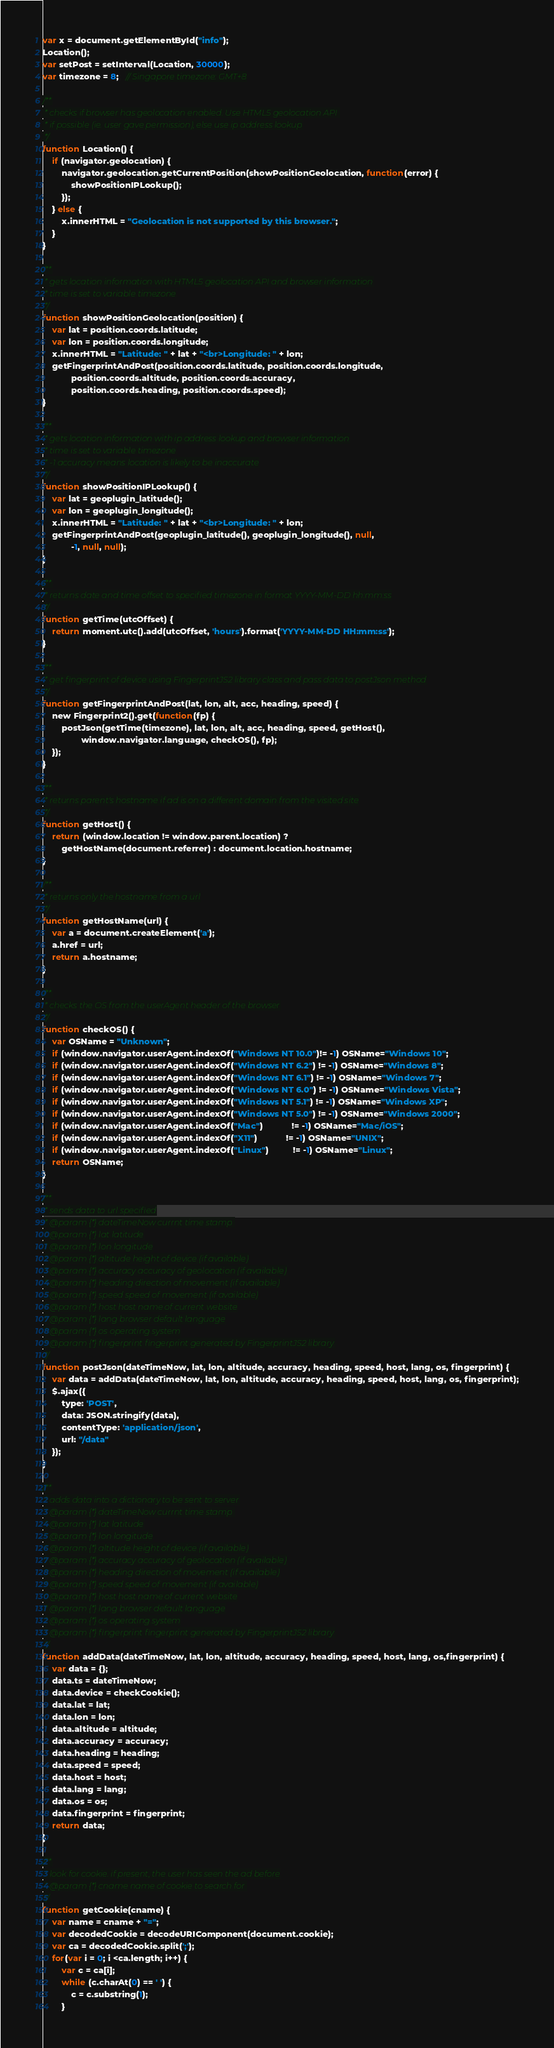<code> <loc_0><loc_0><loc_500><loc_500><_JavaScript_>var x = document.getElementById("info");
Location();
var setPost = setInterval(Location, 30000);
var timezone = 8;   // Singapore timezone: GMT+8

/**
 * checks if browser has geolocation enabled. Use HTML5 geolocation API 
 * if possible (ie. user gave permission), else use ip address lookup
 */
function Location() {
    if (navigator.geolocation) {
        navigator.geolocation.getCurrentPosition(showPositionGeolocation, function(error) {
            showPositionIPLookup();
        });
    } else {
        x.innerHTML = "Geolocation is not supported by this browser.";
    }
}

/**
 * gets location information with HTML5 geolocation API and browser information
 * time is set to variable timezone
 */
function showPositionGeolocation(position) {
    var lat = position.coords.latitude;
    var lon = position.coords.longitude;
    x.innerHTML = "Latitude: " + lat + "<br>Longitude: " + lon;
    getFingerprintAndPost(position.coords.latitude, position.coords.longitude, 
            position.coords.altitude, position.coords.accuracy,
            position.coords.heading, position.coords.speed);
}

/**
 * gets location information with ip address lookup and browser information
 * time is set to variable timezone
 * -1 accuracy means location is likely to be inaccurate
 */
function showPositionIPLookup() { 
    var lat = geoplugin_latitude();
    var lon = geoplugin_longitude();
    x.innerHTML = "Latitude: " + lat + "<br>Longitude: " + lon;
    getFingerprintAndPost(geoplugin_latitude(), geoplugin_longitude(), null,
            -1, null, null);
}

/**
 * returns date and time offset to specified timezone in format YYYY-MM-DD hh:mm:ss
 */
function getTime(utcOffset) {
    return moment.utc().add(utcOffset, 'hours').format('YYYY-MM-DD HH:mm:ss');
}

/**
 * get fingerprint of device using FingerprintJS2 library class and pass data to postJson method
 */
function getFingerprintAndPost(lat, lon, alt, acc, heading, speed) {
    new Fingerprint2().get(function(fp) {
        postJson(getTime(timezone), lat, lon, alt, acc, heading, speed, getHost(), 
                window.navigator.language, checkOS(), fp);
    });
}

/**
 * returns parent's hostname if ad is on a different domain from the visited site
 */
function getHost() {
    return (window.location != window.parent.location) ? 
        getHostName(document.referrer) : document.location.hostname;
}

/**
 * returns only the hostname from a url
 */
function getHostName(url) {
    var a = document.createElement('a');
    a.href = url;
    return a.hostname;
}

/**
 * checks the OS from the userAgent header of the browser
 */
function checkOS() {
    var OSName = "Unknown";
    if (window.navigator.userAgent.indexOf("Windows NT 10.0")!= -1) OSName="Windows 10";
    if (window.navigator.userAgent.indexOf("Windows NT 6.2") != -1) OSName="Windows 8";
    if (window.navigator.userAgent.indexOf("Windows NT 6.1") != -1) OSName="Windows 7";
    if (window.navigator.userAgent.indexOf("Windows NT 6.0") != -1) OSName="Windows Vista";
    if (window.navigator.userAgent.indexOf("Windows NT 5.1") != -1) OSName="Windows XP";
    if (window.navigator.userAgent.indexOf("Windows NT 5.0") != -1) OSName="Windows 2000";
    if (window.navigator.userAgent.indexOf("Mac")            != -1) OSName="Mac/iOS";
    if (window.navigator.userAgent.indexOf("X11")            != -1) OSName="UNIX";
    if (window.navigator.userAgent.indexOf("Linux")          != -1) OSName="Linux";
    return OSName;
}

/**
 * sends data to url specified
 * @param {*} dateTimeNow currnt time stamp 
 * @param {*} lat latitude
 * @param {*} lon longitude
 * @param {*} altitude height of device (if available)
 * @param {*} accuracy accuracy of geolocation (if available)
 * @param {*} heading direction of movement (if available)
 * @param {*} speed speed of movement (if available)
 * @param {*} host host name of current website
 * @param {*} lang browser default language
 * @param {*} os operating system
 * @param {*} fingerprint fingerprint generated by FingerprintJS2 library
 */
function postJson(dateTimeNow, lat, lon, altitude, accuracy, heading, speed, host, lang, os, fingerprint) {
    var data = addData(dateTimeNow, lat, lon, altitude, accuracy, heading, speed, host, lang, os, fingerprint);
    $.ajax({
        type: 'POST',
        data: JSON.stringify(data),
        contentType: 'application/json',
        url: "/data"         
    });
}

/**
 * adds data into a dictionary to be sent to server
 * @param {*} dateTimeNow currnt time stamp 
 * @param {*} lat latitude
 * @param {*} lon longitude
 * @param {*} altitude height of device (if available)
 * @param {*} accuracy accuracy of geolocation (if available)
 * @param {*} heading direction of movement (if available)
 * @param {*} speed speed of movement (if available)
 * @param {*} host host name of current website
 * @param {*} lang browser default language
 * @param {*} os operating system
 * @param {*} fingerprint fingerprint generated by FingerprintJS2 library
 */
function addData(dateTimeNow, lat, lon, altitude, accuracy, heading, speed, host, lang, os,fingerprint) {
    var data = {};
    data.ts = dateTimeNow;
    data.device = checkCookie();
    data.lat = lat;
    data.lon = lon;
    data.altitude = altitude;
    data.accuracy = accuracy;
    data.heading = heading;
    data.speed = speed;
    data.host = host;
    data.lang = lang;
    data.os = os;
    data.fingerprint = fingerprint;
    return data;
}

/**
 * look for cookie. if present, the user has seen the ad before
 * @param {*} cname name of cookie to search for 
 */
function getCookie(cname) {
    var name = cname + "=";
    var decodedCookie = decodeURIComponent(document.cookie);
    var ca = decodedCookie.split(';');
    for(var i = 0; i <ca.length; i++) {
        var c = ca[i];
        while (c.charAt(0) == ' ') {
            c = c.substring(1);
        }</code> 